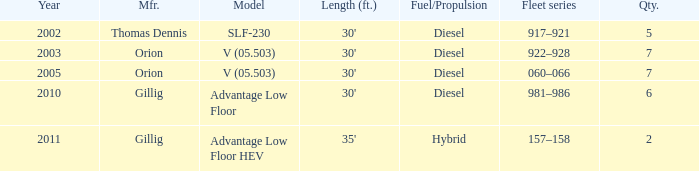Tell me the model with fuel or propulsion of diesel and orion manufacturer in 2005 V (05.503). 